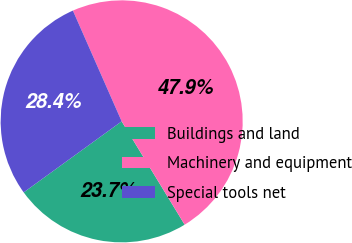Convert chart. <chart><loc_0><loc_0><loc_500><loc_500><pie_chart><fcel>Buildings and land<fcel>Machinery and equipment<fcel>Special tools net<nl><fcel>23.73%<fcel>47.89%<fcel>28.38%<nl></chart> 